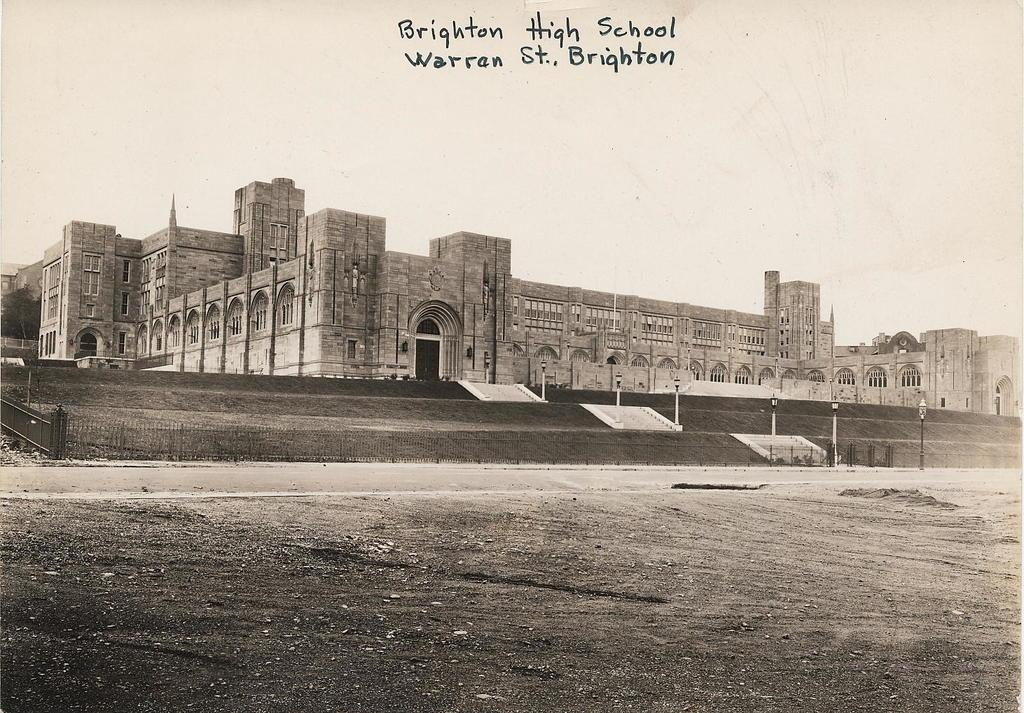<image>
Render a clear and concise summary of the photo. A old photo that has the words Brighton High School Warran St., Brighton written on it. 